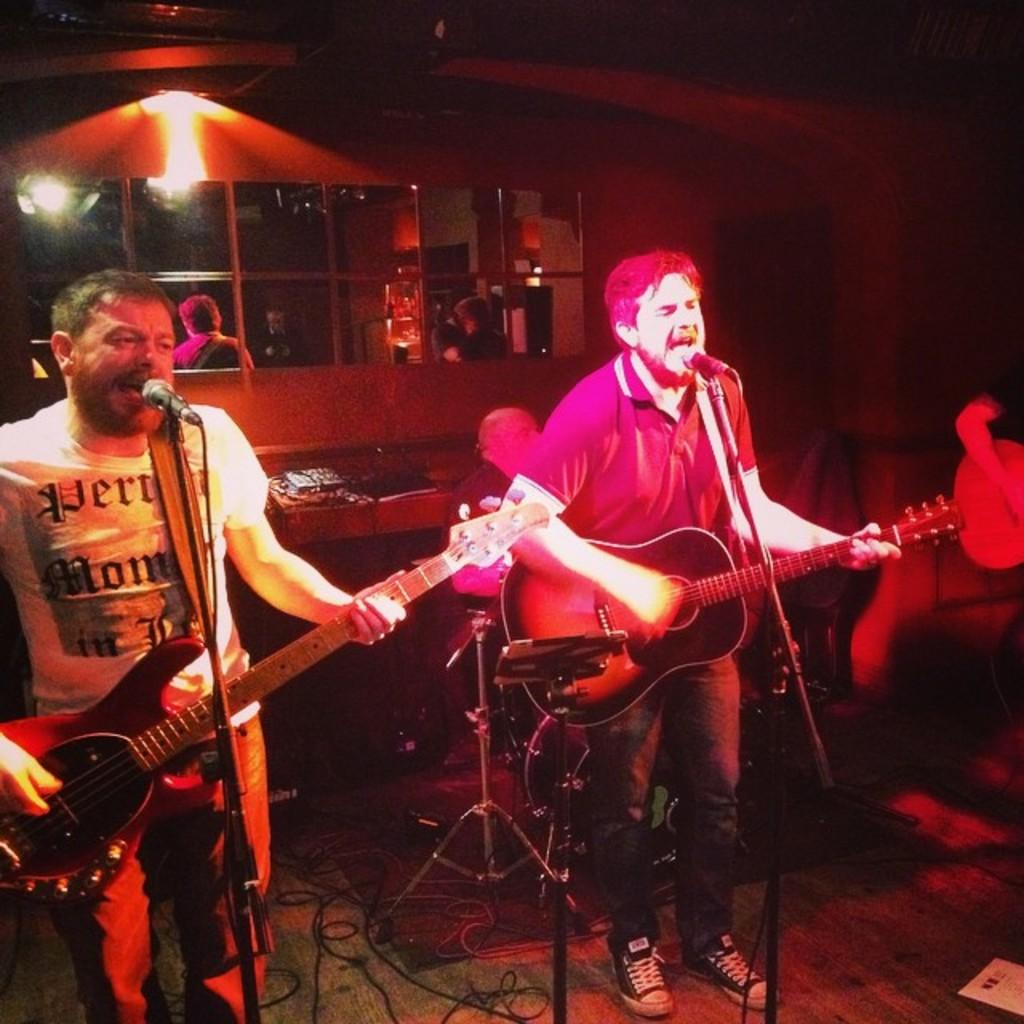How many people are present in the image? There are two men in the image. What are the men doing in the image? The men are standing and playing a guitar. What object is present for amplifying sound? There is a microphone in the image. Can you describe the background of the image? There are people in the background of the image. What type of light source is visible in the image? There is a light in the image. What type of spade is being used by the passenger in the image? There is no passenger or spade present in the image. What type of band are the men in the image part of? The image does not provide information about any band; it only shows two men playing a guitar and standing near a microphone. 